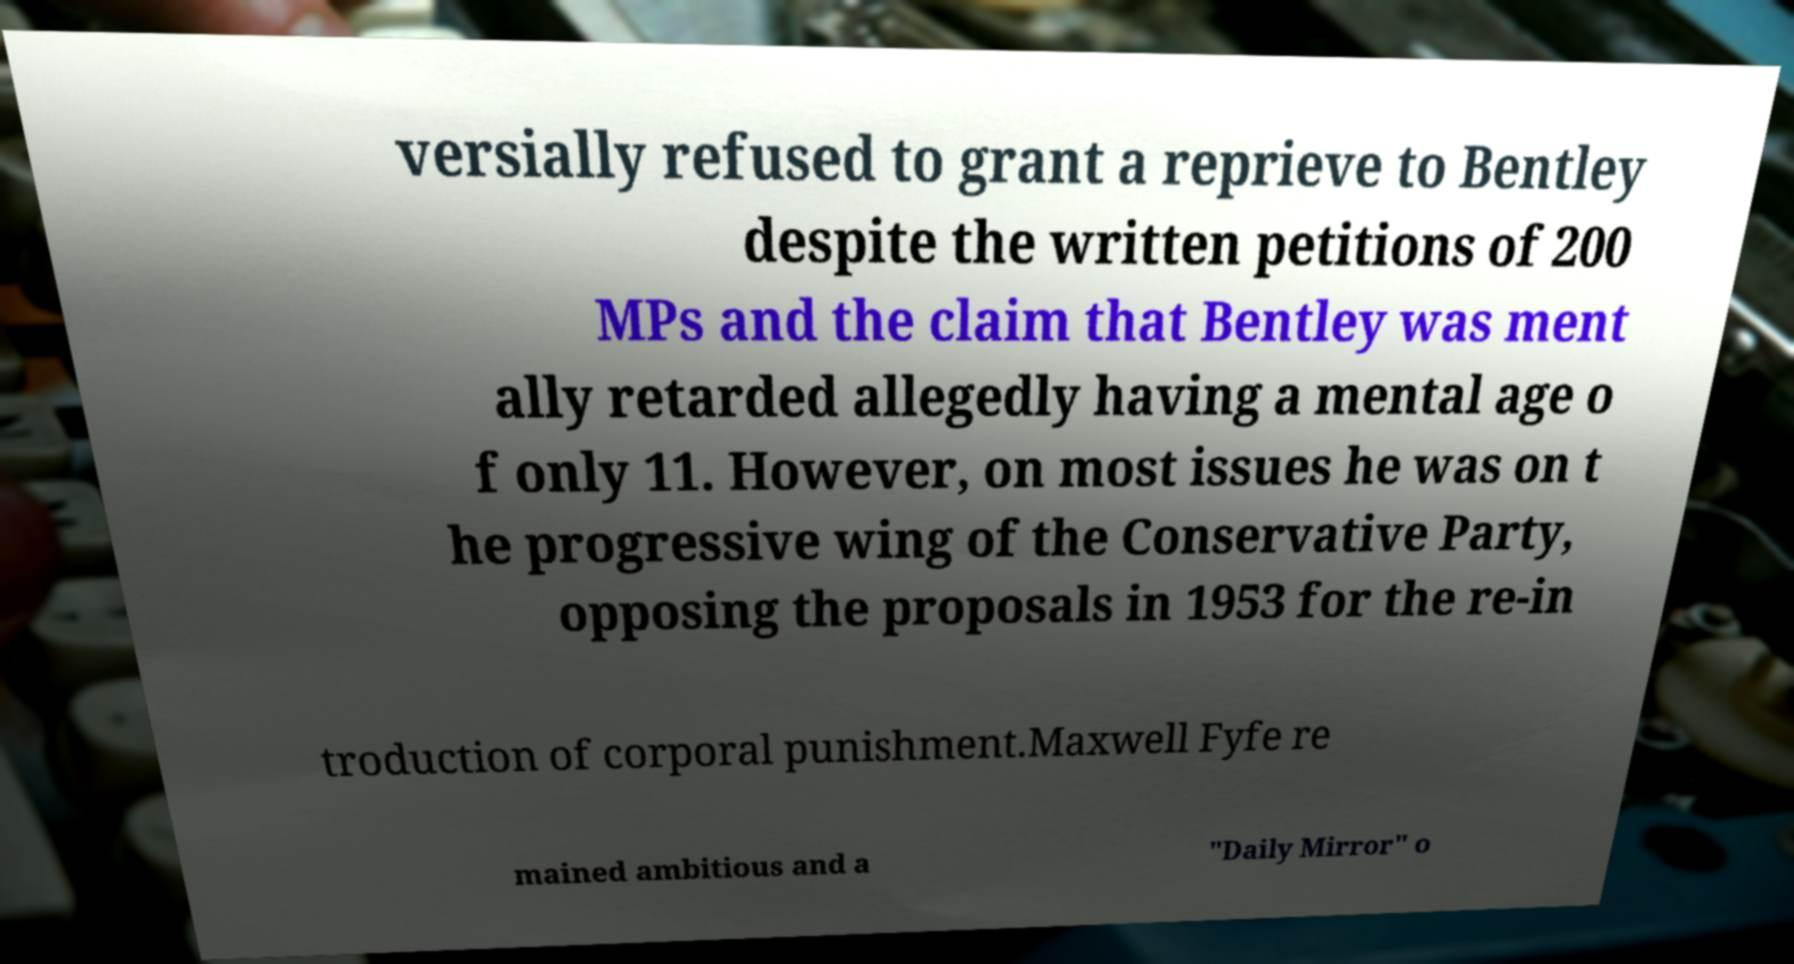There's text embedded in this image that I need extracted. Can you transcribe it verbatim? versially refused to grant a reprieve to Bentley despite the written petitions of 200 MPs and the claim that Bentley was ment ally retarded allegedly having a mental age o f only 11. However, on most issues he was on t he progressive wing of the Conservative Party, opposing the proposals in 1953 for the re-in troduction of corporal punishment.Maxwell Fyfe re mained ambitious and a "Daily Mirror" o 